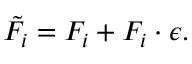Convert formula to latex. <formula><loc_0><loc_0><loc_500><loc_500>\tilde { F } _ { i } = F _ { i } + F _ { i } \cdot \epsilon .</formula> 